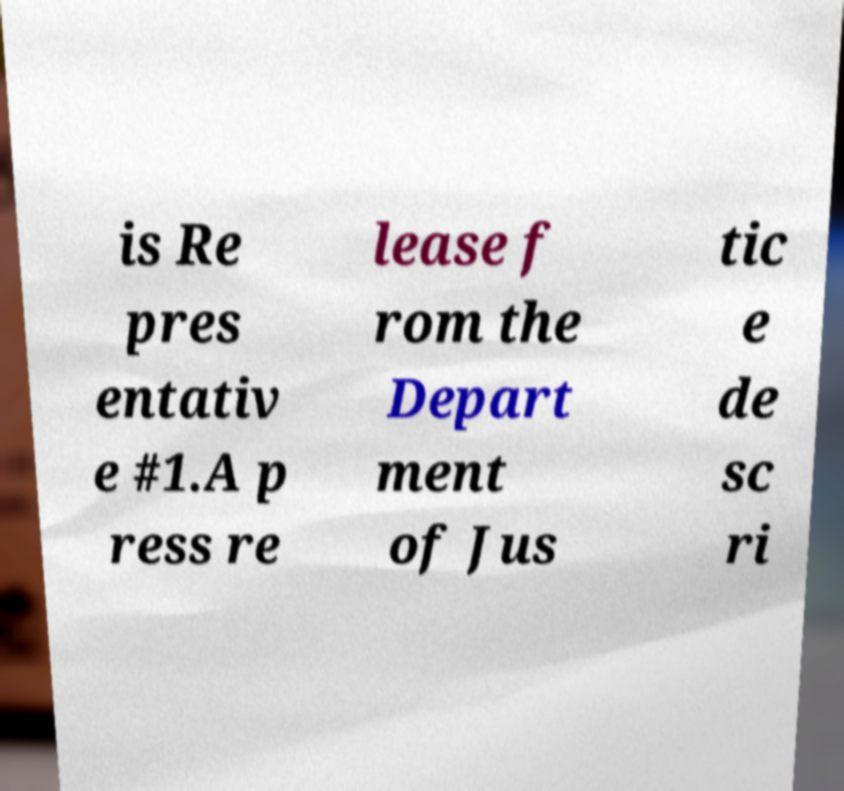Can you accurately transcribe the text from the provided image for me? is Re pres entativ e #1.A p ress re lease f rom the Depart ment of Jus tic e de sc ri 